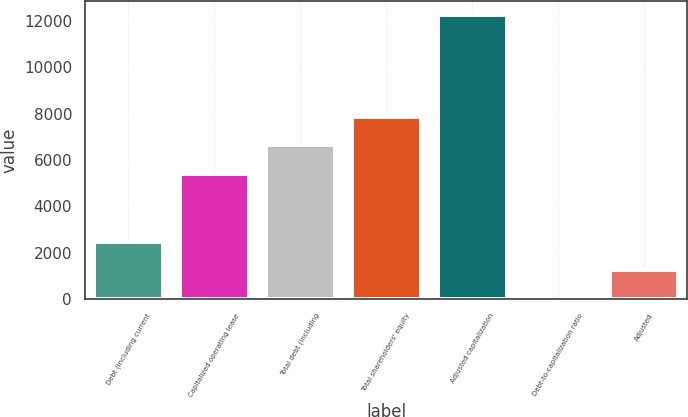<chart> <loc_0><loc_0><loc_500><loc_500><bar_chart><fcel>Debt (including current<fcel>Capitalized operating lease<fcel>Total debt (including<fcel>Total shareholders' equity<fcel>Adjusted capitalization<fcel>Debt-to-capitalization ratio<fcel>Adjusted<nl><fcel>2457.6<fcel>5401<fcel>6625.3<fcel>7849.6<fcel>12252<fcel>9<fcel>1233.3<nl></chart> 